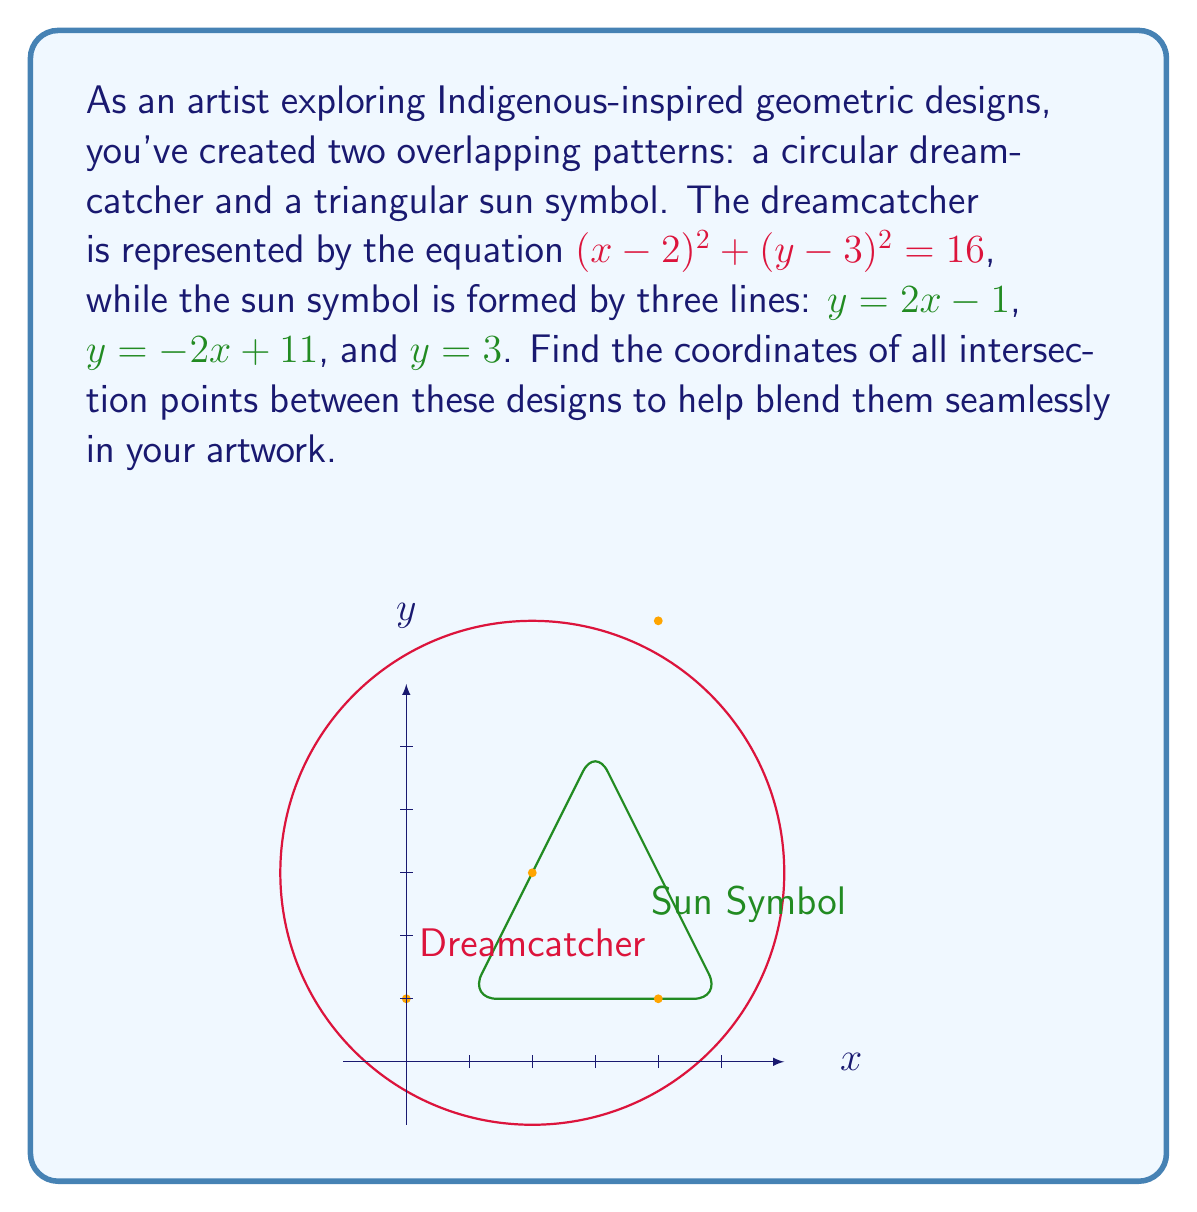Solve this math problem. Let's approach this step-by-step:

1) First, let's find the intersection points of the circle with the line $y = 2x-1$:
   Substitute $y$ in the circle equation:
   $$(x-2)^2 + ((2x-1)-3)^2 = 16$$
   $$(x-2)^2 + (2x-4)^2 = 16$$
   $$x^2 - 4x + 4 + 4x^2 - 16x + 16 = 16$$
   $$5x^2 - 20x + 4 = 0$$
   $$x^2 - 4x + 0.8 = 0$$
   Using the quadratic formula, we get:
   $$x = 2 \pm \sqrt{4 - 0.8} = 2 \pm \sqrt{3.2} = 2 \pm 1.789$$
   $$x_1 \approx 0.211, x_2 \approx 3.789$$
   Corresponding $y$ values:
   $$y_1 \approx -0.578, y_2 \approx 6.578$$
   The point $(3.789, 6.578)$ is outside our triangle, so we discard it.

2) For the line $y = -2x+11$:
   $$(x-2)^2 + ((-2x+11)-3)^2 = 16$$
   $$(x-2)^2 + (-2x+8)^2 = 16$$
   $$x^2 - 4x + 4 + 4x^2 - 32x + 64 = 16$$
   $$5x^2 - 36x + 52 = 0$$
   $$x^2 - 7.2x + 10.4 = 0$$
   $$x = 3.6 \pm \sqrt{3.6^2 - 10.4} = 3.6 \pm 2.4$$
   $$x_1 = 6, x_2 = 1.2$$
   $$y_1 = -1, y_2 = 8.6$$
   The point $(6, -1)$ is outside our design, so we discard it.

3) For the line $y = 3$:
   $$(x-2)^2 + (3-3)^2 = 16$$
   $$(x-2)^2 = 16$$
   $$x-2 = \pm 4$$
   $$x = 6 \text{ or } x = -2$$
   Both these x-values are outside our design, so we discard them.

4) Now, let's find the intersection of the lines:
   $2x-1 = -2x+11$ gives $x = 3, y = 5$
   $2x-1 = 3$ gives $x = 2, y = 3$
   $-2x+11 = 3$ gives $x = 4, y = 3$

Therefore, the intersection points within our design are:
$(0.211, -0.578)$, $(2, 3)$, $(3, 5)$, and $(4, 3)$.
Answer: $(0.211, -0.578)$, $(2, 3)$, $(3, 5)$, $(4, 3)$ 